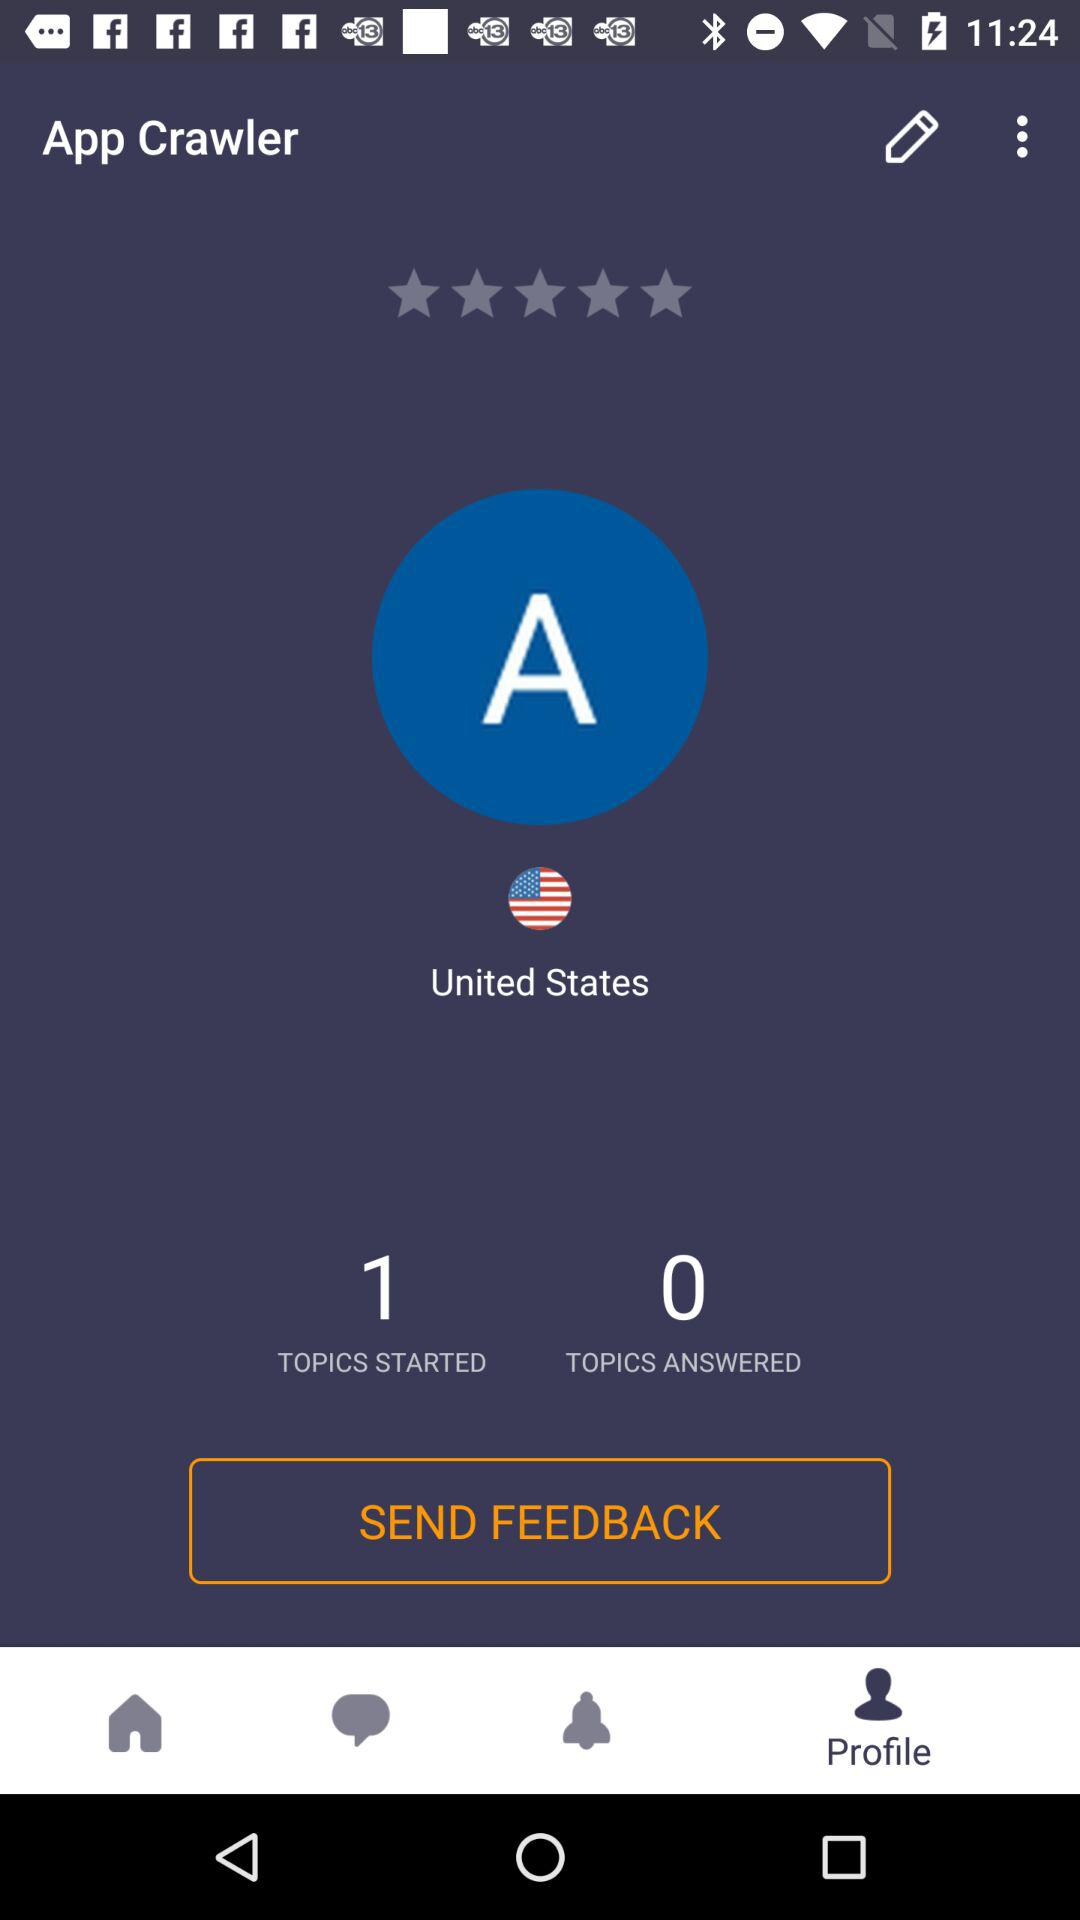What is the country name? The country name is "United States". 